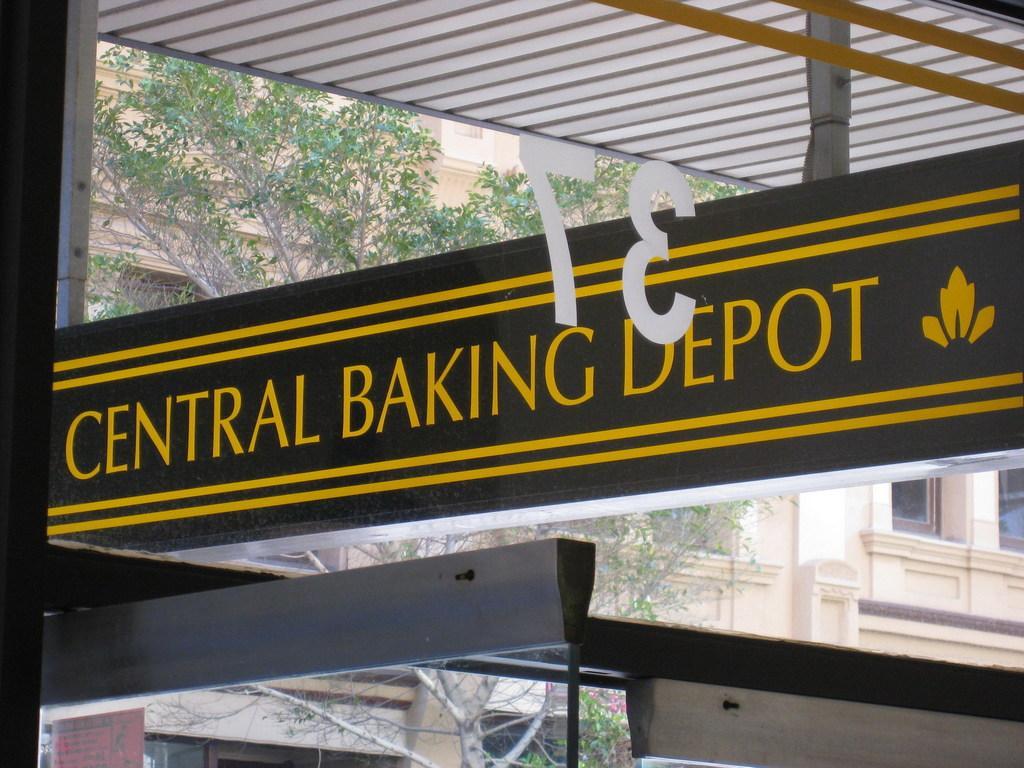Can you describe this image briefly? This image consists of glass on which we can see a sticker. At the top, there is a shed. In the background, there are trees along with the buildings. 